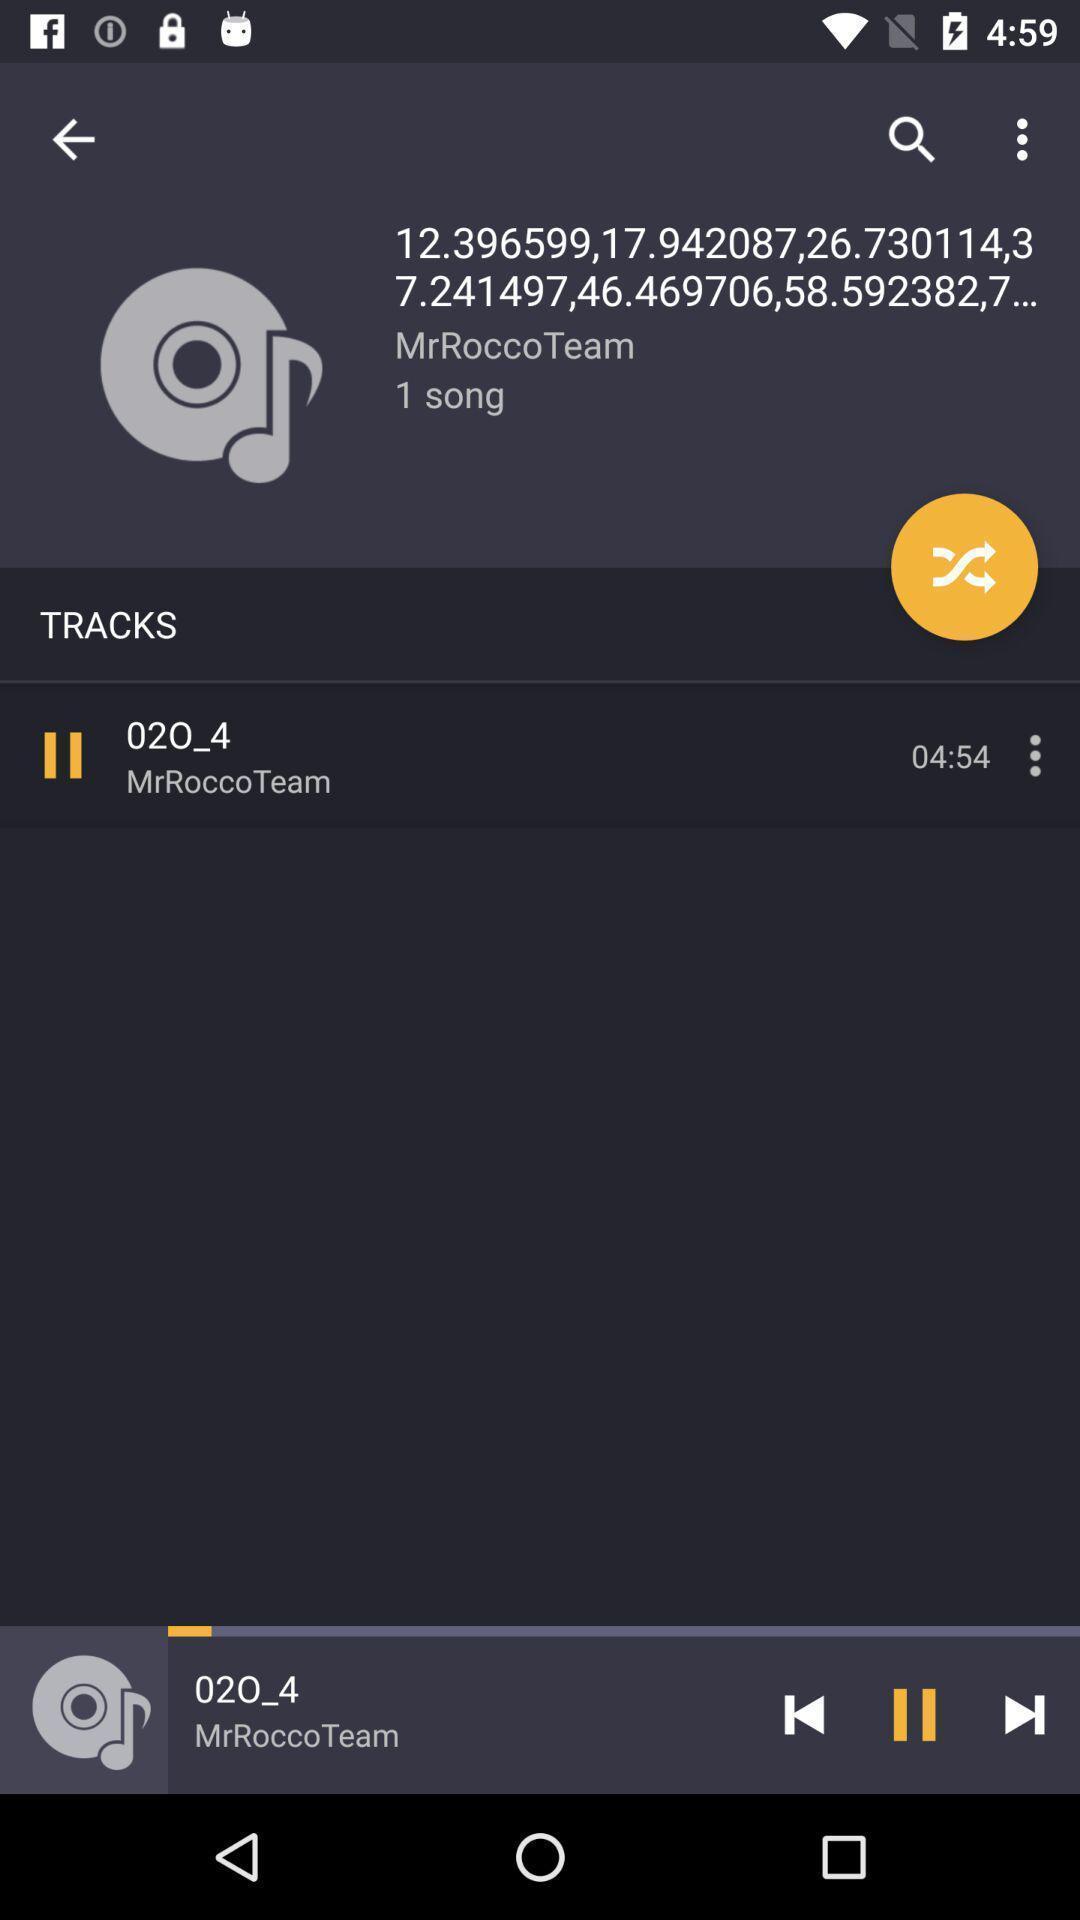Provide a detailed account of this screenshot. Screen showing a track is playing in a music app. 